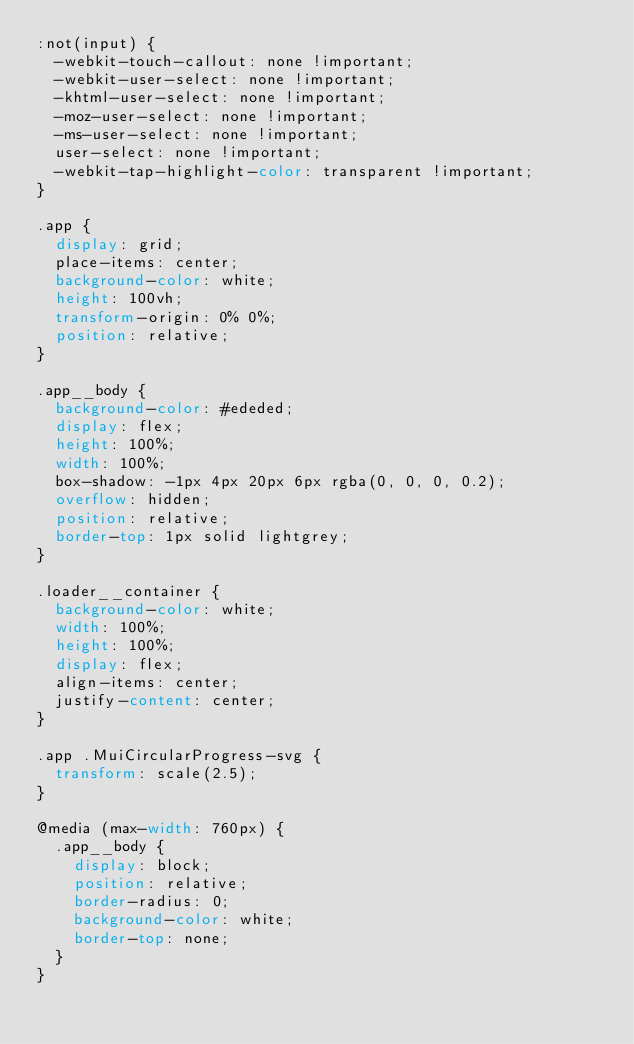Convert code to text. <code><loc_0><loc_0><loc_500><loc_500><_CSS_>:not(input) {
  -webkit-touch-callout: none !important;
  -webkit-user-select: none !important;
  -khtml-user-select: none !important;
  -moz-user-select: none !important;
  -ms-user-select: none !important;
  user-select: none !important;
  -webkit-tap-highlight-color: transparent !important;
}

.app {
  display: grid;
  place-items: center;
  background-color: white;
  height: 100vh;
  transform-origin: 0% 0%;
  position: relative;
}

.app__body {
  background-color: #ededed;
  display: flex;
  height: 100%;
  width: 100%;
  box-shadow: -1px 4px 20px 6px rgba(0, 0, 0, 0.2);
  overflow: hidden;
  position: relative;
  border-top: 1px solid lightgrey;
}

.loader__container {
  background-color: white;
  width: 100%;
  height: 100%;
  display: flex;
  align-items: center;
  justify-content: center;
}

.app .MuiCircularProgress-svg {
  transform: scale(2.5);
}

@media (max-width: 760px) {
  .app__body {
    display: block;
    position: relative;
    border-radius: 0;
    background-color: white;
    border-top: none;
  }
}
</code> 